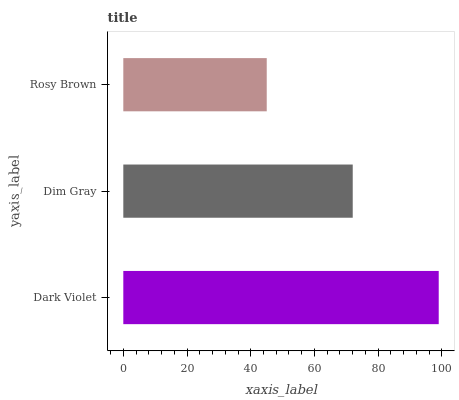Is Rosy Brown the minimum?
Answer yes or no. Yes. Is Dark Violet the maximum?
Answer yes or no. Yes. Is Dim Gray the minimum?
Answer yes or no. No. Is Dim Gray the maximum?
Answer yes or no. No. Is Dark Violet greater than Dim Gray?
Answer yes or no. Yes. Is Dim Gray less than Dark Violet?
Answer yes or no. Yes. Is Dim Gray greater than Dark Violet?
Answer yes or no. No. Is Dark Violet less than Dim Gray?
Answer yes or no. No. Is Dim Gray the high median?
Answer yes or no. Yes. Is Dim Gray the low median?
Answer yes or no. Yes. Is Dark Violet the high median?
Answer yes or no. No. Is Rosy Brown the low median?
Answer yes or no. No. 